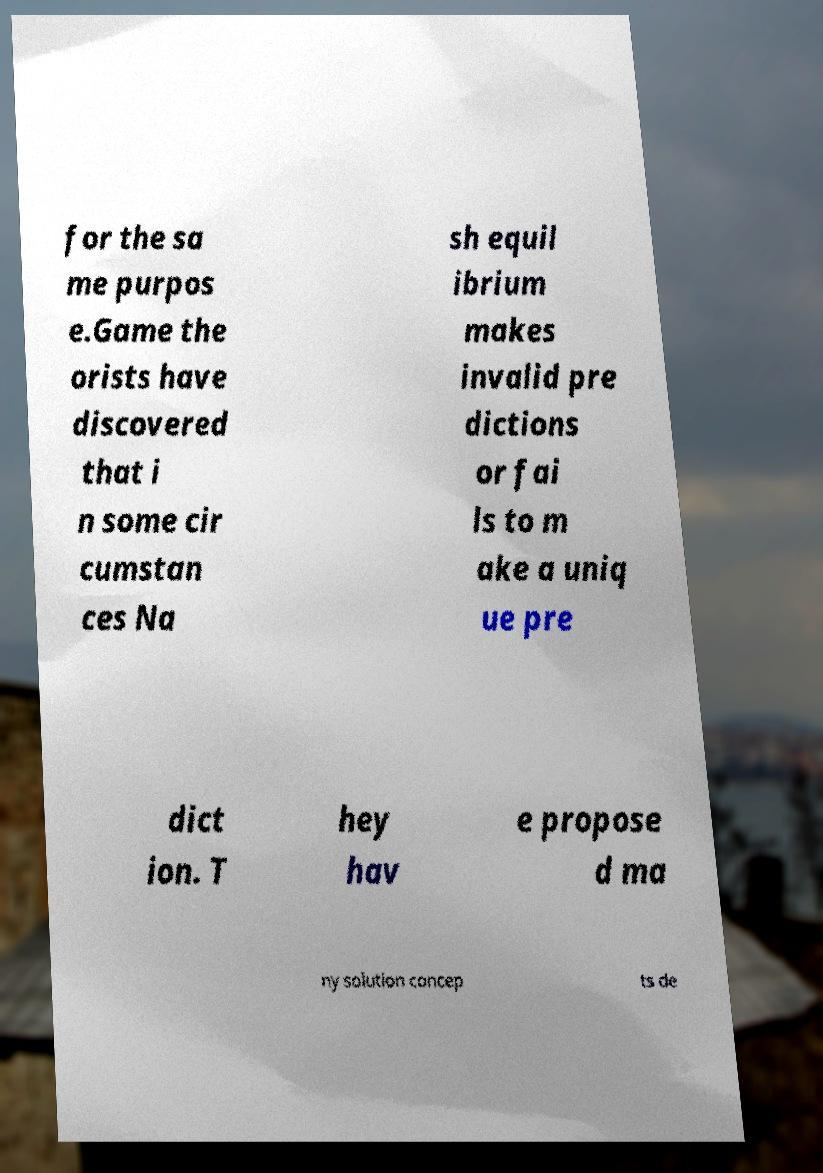For documentation purposes, I need the text within this image transcribed. Could you provide that? for the sa me purpos e.Game the orists have discovered that i n some cir cumstan ces Na sh equil ibrium makes invalid pre dictions or fai ls to m ake a uniq ue pre dict ion. T hey hav e propose d ma ny solution concep ts de 